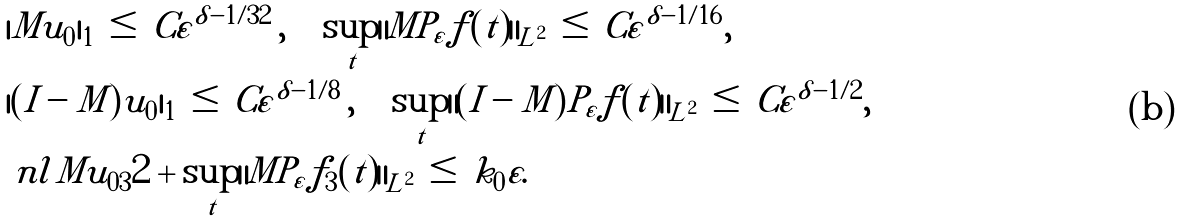Convert formula to latex. <formula><loc_0><loc_0><loc_500><loc_500>& | M u _ { 0 } | _ { 1 } \, \leq \, C \varepsilon ^ { \delta - 1 / 3 2 } \, , \quad \sup _ { t } \| M P _ { \varepsilon } f ( t ) \| _ { L ^ { 2 } } \, \leq \, C \varepsilon ^ { \delta - 1 / 1 6 } , \\ & | ( I - M ) u _ { 0 } | _ { 1 } \, \leq \, C \varepsilon ^ { \delta - 1 / 8 } \, , \quad \sup _ { t } \| ( I - M ) P _ { \varepsilon } f ( t ) \| _ { L ^ { 2 } } \, \leq \, C \varepsilon ^ { \delta - 1 / 2 } , \\ & \ n l { M u _ { 0 3 } } { 2 } + \sup _ { t } \| M P _ { \varepsilon } f _ { 3 } ( t ) \| _ { L ^ { 2 } } \, \leq \, k _ { 0 } \varepsilon .</formula> 